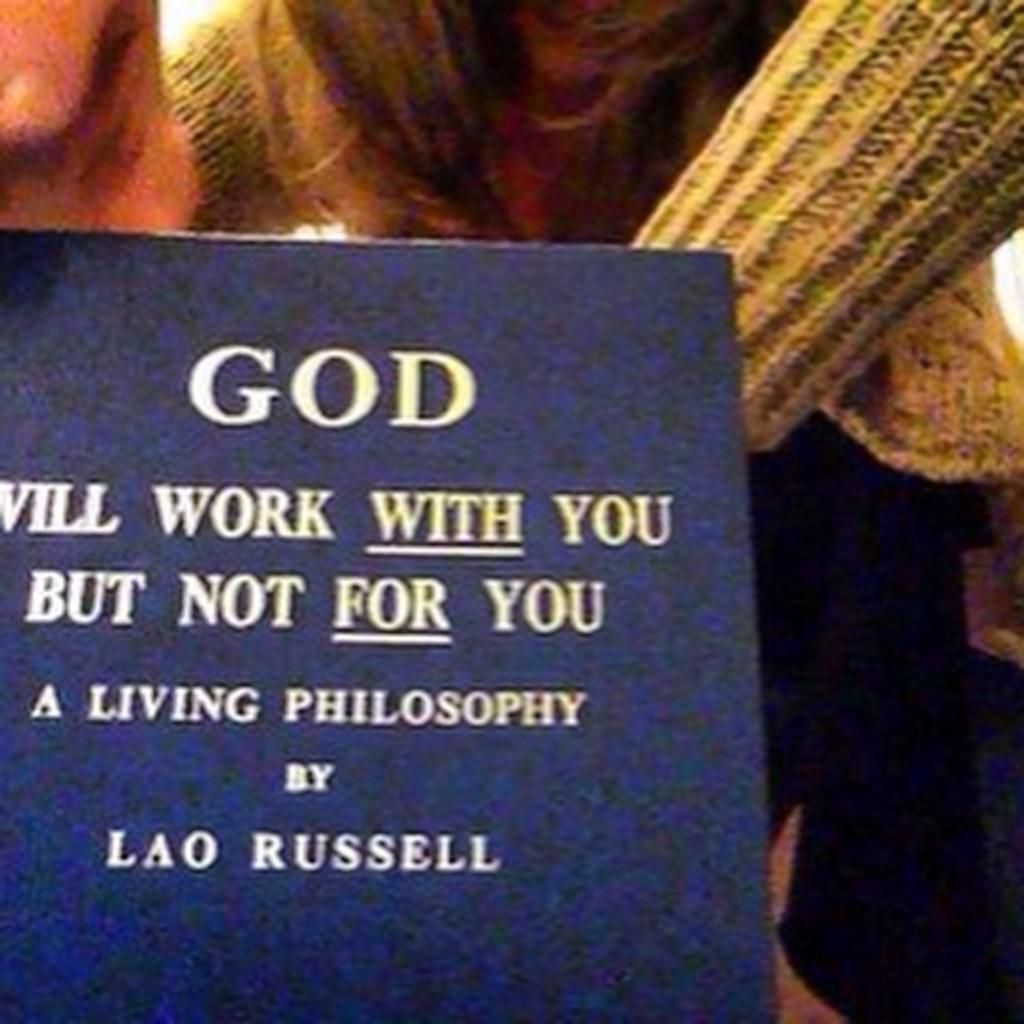What object is located in the left corner of the image? There is a book in the left corner of the image. What can be seen on the book? There is writing on the book. Can you describe the person behind the book? There is a person with a jacket behind the book. What type of bird can be seen perched on the person's shoulder in the image? There is no bird present in the image; it only features a book, writing, and a person with a jacket. 